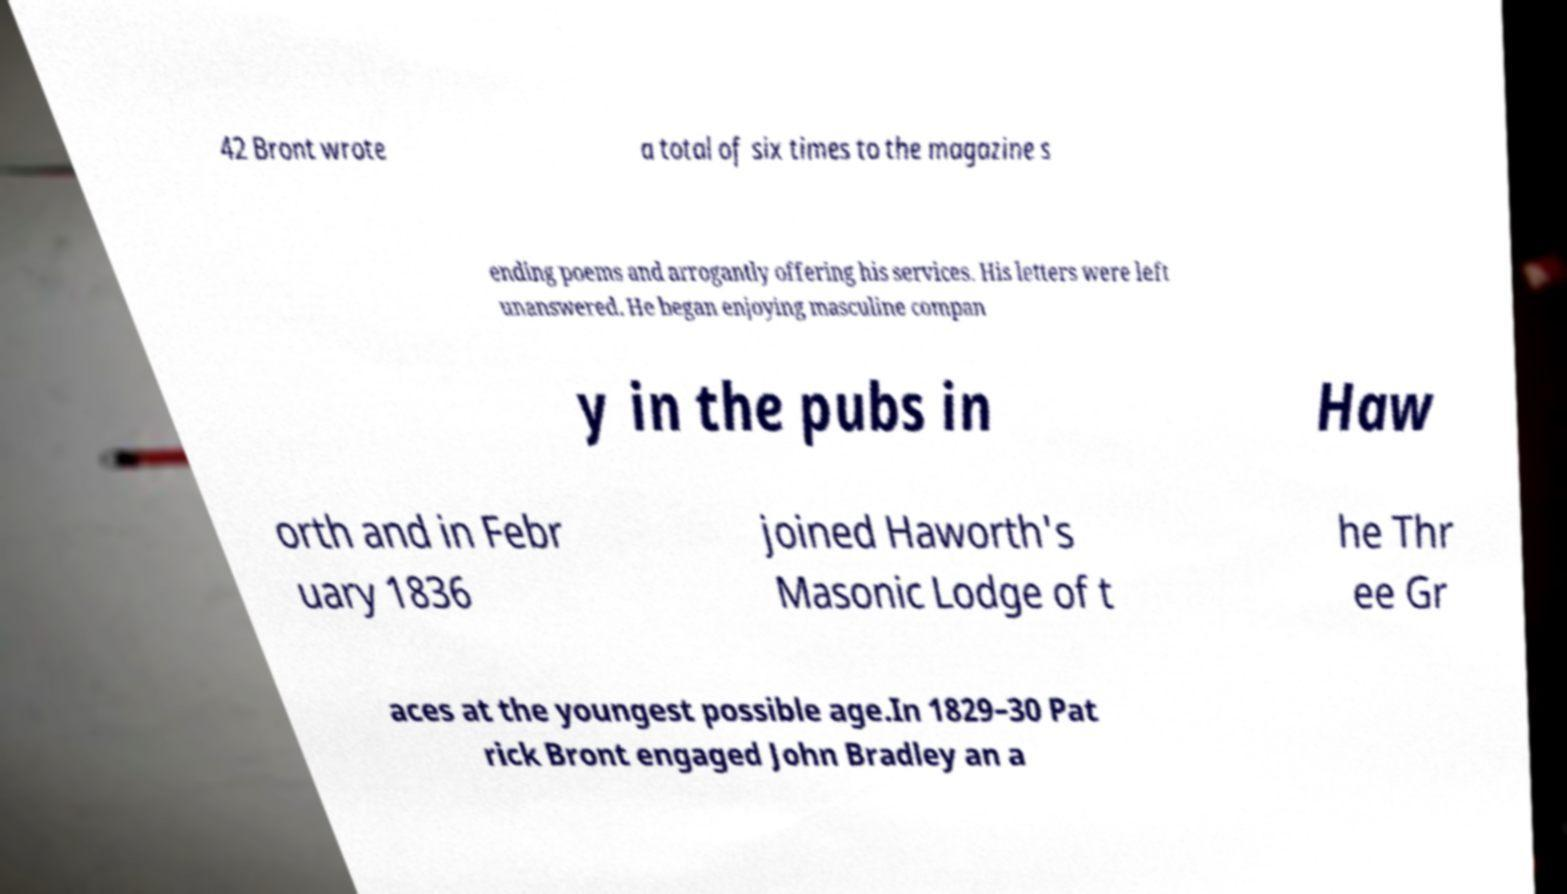Could you assist in decoding the text presented in this image and type it out clearly? 42 Bront wrote a total of six times to the magazine s ending poems and arrogantly offering his services. His letters were left unanswered. He began enjoying masculine compan y in the pubs in Haw orth and in Febr uary 1836 joined Haworth's Masonic Lodge of t he Thr ee Gr aces at the youngest possible age.In 1829–30 Pat rick Bront engaged John Bradley an a 